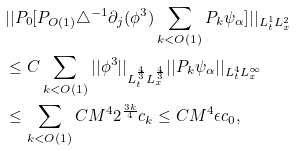Convert formula to latex. <formula><loc_0><loc_0><loc_500><loc_500>& | | P _ { 0 } [ P _ { O ( 1 ) } \triangle ^ { - 1 } \partial _ { j } ( \phi ^ { 3 } ) \sum _ { k < O ( 1 ) } P _ { k } \psi _ { \alpha } ] | | _ { L _ { t } ^ { 1 } L _ { x } ^ { 2 } } \\ & \leq C \sum _ { k < O ( 1 ) } | | \phi ^ { 3 } | | _ { L _ { t } ^ { \frac { 4 } { 3 } } L _ { x } ^ { \frac { 4 } { 3 } } } | | P _ { k } \psi _ { \alpha } | | _ { L _ { t } ^ { 4 } L _ { x } ^ { \infty } } \\ & \leq \sum _ { k < O ( 1 ) } C M ^ { 4 } 2 ^ { \frac { 3 k } { 4 } } c _ { k } \leq C M ^ { 4 } \epsilon c _ { 0 } , \\</formula> 